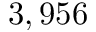<formula> <loc_0><loc_0><loc_500><loc_500>3 , 9 5 6</formula> 